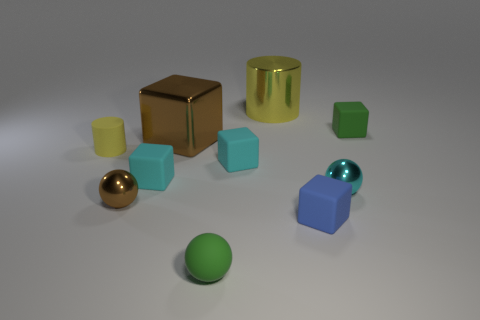Subtract all yellow balls. How many cyan blocks are left? 2 Subtract all small green matte cubes. How many cubes are left? 4 Subtract all green cubes. How many cubes are left? 4 Subtract 1 cubes. How many cubes are left? 4 Subtract all cylinders. How many objects are left? 8 Subtract all gray blocks. Subtract all green balls. How many blocks are left? 5 Subtract all yellow matte cylinders. Subtract all cyan rubber things. How many objects are left? 7 Add 4 large shiny cylinders. How many large shiny cylinders are left? 5 Add 8 brown matte blocks. How many brown matte blocks exist? 8 Subtract 1 blue blocks. How many objects are left? 9 